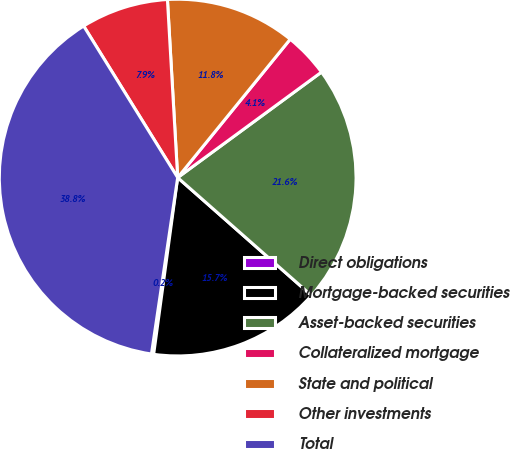Convert chart. <chart><loc_0><loc_0><loc_500><loc_500><pie_chart><fcel>Direct obligations<fcel>Mortgage-backed securities<fcel>Asset-backed securities<fcel>Collateralized mortgage<fcel>State and political<fcel>Other investments<fcel>Total<nl><fcel>0.2%<fcel>15.65%<fcel>21.57%<fcel>4.06%<fcel>11.78%<fcel>7.92%<fcel>38.81%<nl></chart> 